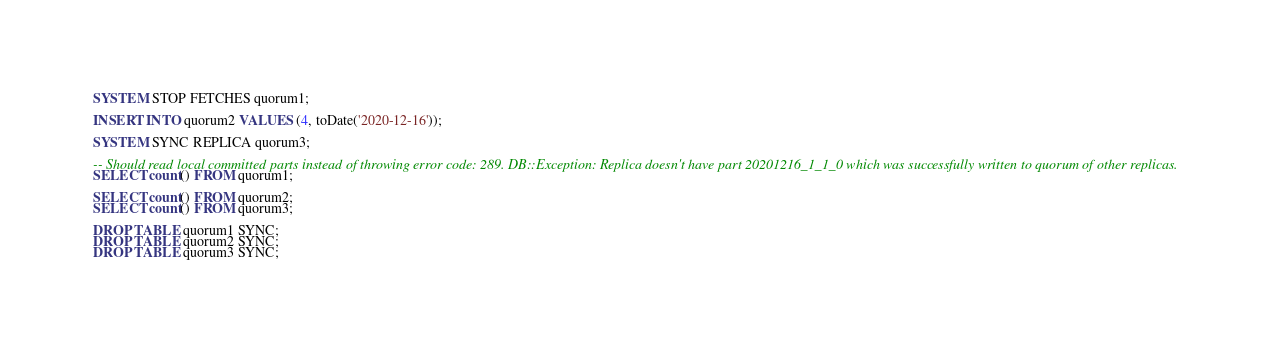<code> <loc_0><loc_0><loc_500><loc_500><_SQL_>
SYSTEM STOP FETCHES quorum1;

INSERT INTO quorum2 VALUES (4, toDate('2020-12-16'));

SYSTEM SYNC REPLICA quorum3;

-- Should read local committed parts instead of throwing error code: 289. DB::Exception: Replica doesn't have part 20201216_1_1_0 which was successfully written to quorum of other replicas.
SELECT count() FROM quorum1;

SELECT count() FROM quorum2;
SELECT count() FROM quorum3;

DROP TABLE quorum1 SYNC;
DROP TABLE quorum2 SYNC;
DROP TABLE quorum3 SYNC;
</code> 